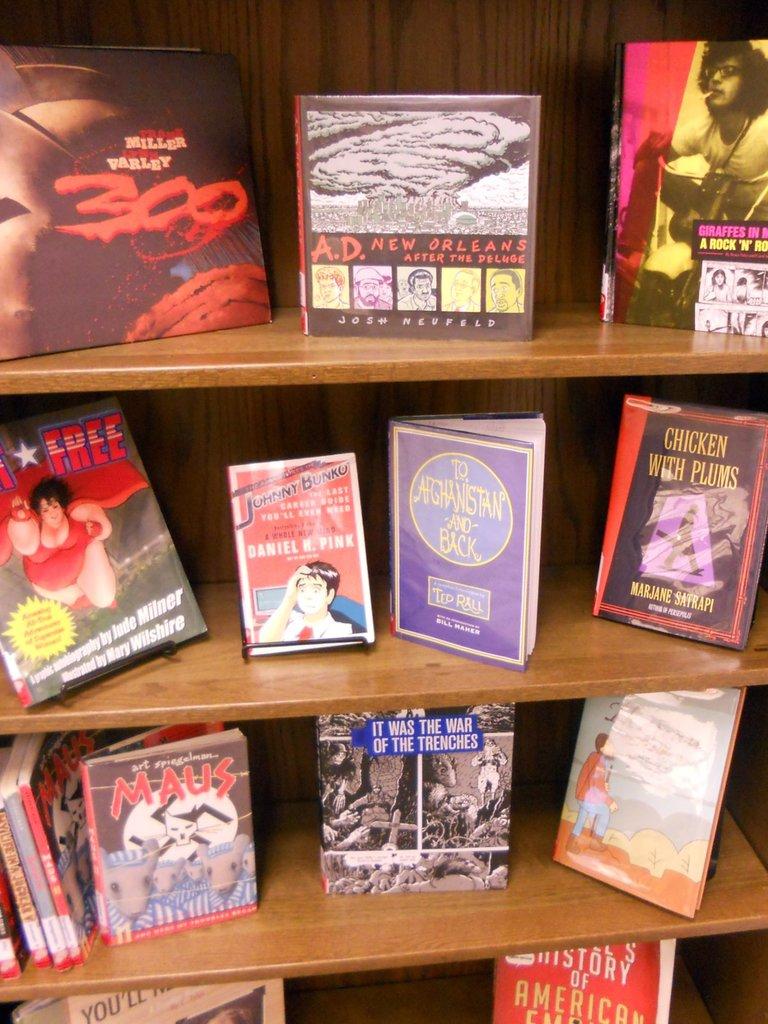What are the titles of these books?
Offer a very short reply. 300. Who wrote the book on the top in the middle?
Provide a succinct answer. Josh neufeld. 